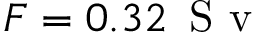<formula> <loc_0><loc_0><loc_500><loc_500>F = 0 . 3 2 \, S v</formula> 